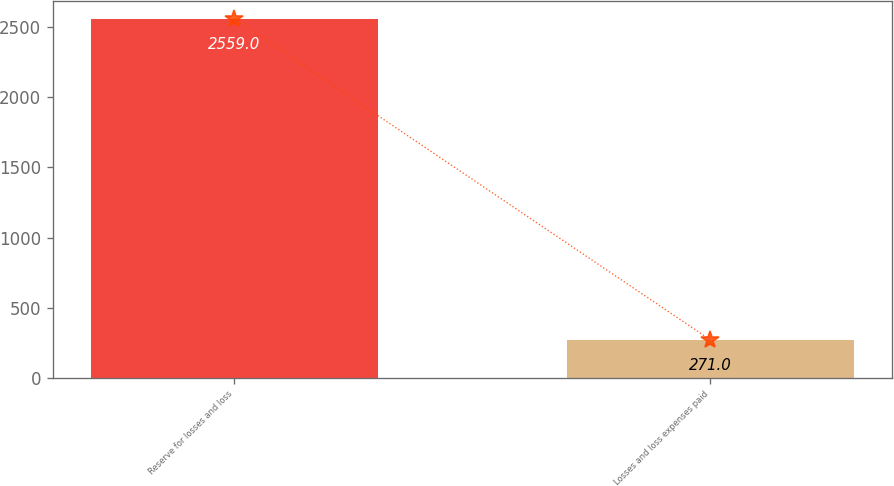<chart> <loc_0><loc_0><loc_500><loc_500><bar_chart><fcel>Reserve for losses and loss<fcel>Losses and loss expenses paid<nl><fcel>2559<fcel>271<nl></chart> 